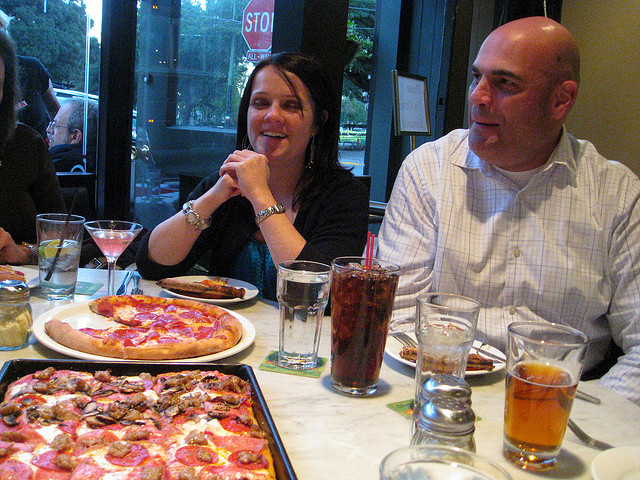Identify the text displayed in this image. STOP 